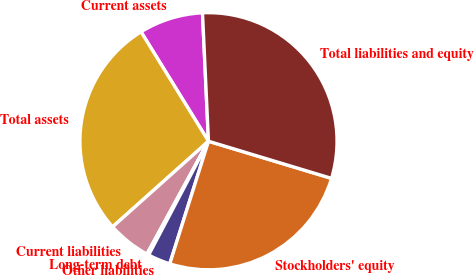Convert chart. <chart><loc_0><loc_0><loc_500><loc_500><pie_chart><fcel>Current assets<fcel>Total assets<fcel>Current liabilities<fcel>Long-term debt<fcel>Other liabilities<fcel>Stockholders' equity<fcel>Total liabilities and equity<nl><fcel>8.05%<fcel>27.81%<fcel>5.45%<fcel>0.24%<fcel>2.84%<fcel>25.2%<fcel>30.41%<nl></chart> 